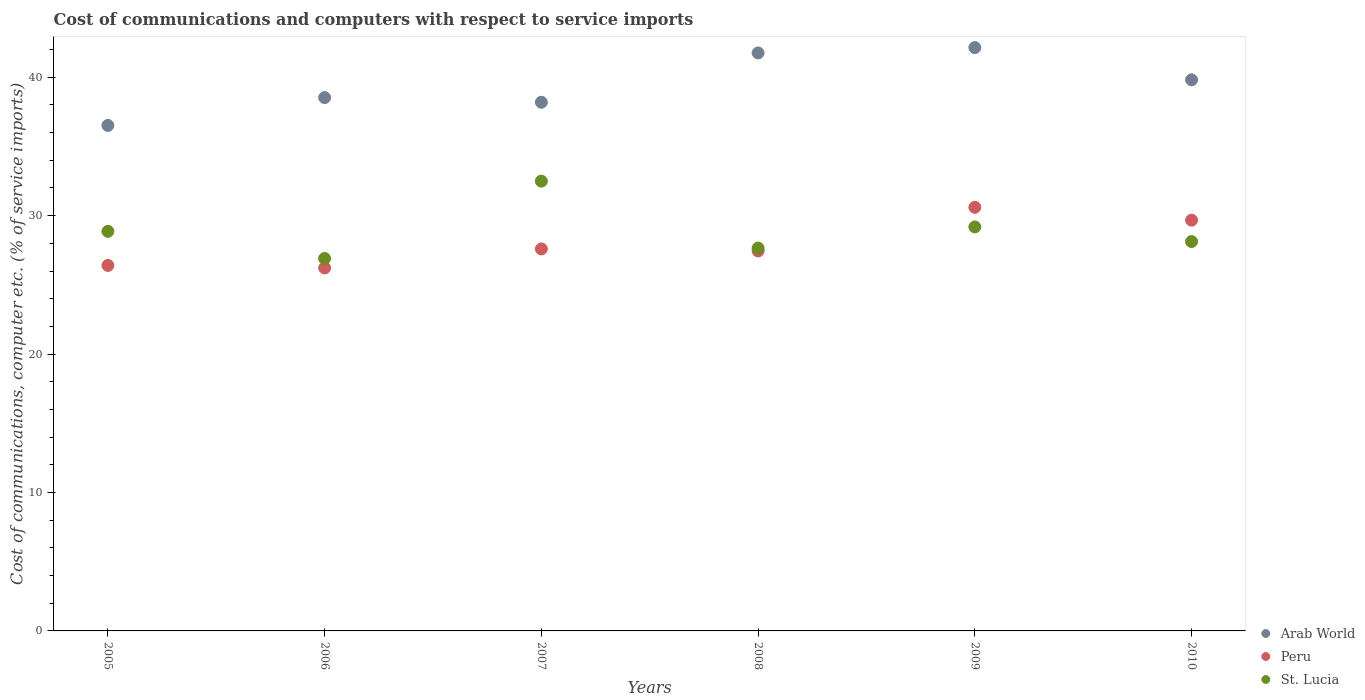How many different coloured dotlines are there?
Your answer should be very brief. 3. What is the cost of communications and computers in St. Lucia in 2005?
Your response must be concise. 28.86. Across all years, what is the maximum cost of communications and computers in Peru?
Give a very brief answer. 30.6. Across all years, what is the minimum cost of communications and computers in St. Lucia?
Offer a very short reply. 26.91. In which year was the cost of communications and computers in St. Lucia maximum?
Provide a succinct answer. 2007. What is the total cost of communications and computers in Peru in the graph?
Your response must be concise. 167.94. What is the difference between the cost of communications and computers in Arab World in 2007 and that in 2009?
Offer a very short reply. -3.95. What is the difference between the cost of communications and computers in St. Lucia in 2005 and the cost of communications and computers in Peru in 2007?
Your response must be concise. 1.27. What is the average cost of communications and computers in Peru per year?
Offer a very short reply. 27.99. In the year 2006, what is the difference between the cost of communications and computers in Peru and cost of communications and computers in Arab World?
Give a very brief answer. -12.3. In how many years, is the cost of communications and computers in Peru greater than 38 %?
Offer a very short reply. 0. What is the ratio of the cost of communications and computers in Peru in 2005 to that in 2009?
Give a very brief answer. 0.86. Is the cost of communications and computers in St. Lucia in 2008 less than that in 2009?
Offer a very short reply. Yes. Is the difference between the cost of communications and computers in Peru in 2008 and 2009 greater than the difference between the cost of communications and computers in Arab World in 2008 and 2009?
Your answer should be very brief. No. What is the difference between the highest and the second highest cost of communications and computers in Peru?
Offer a terse response. 0.93. What is the difference between the highest and the lowest cost of communications and computers in St. Lucia?
Ensure brevity in your answer.  5.59. Is the sum of the cost of communications and computers in Peru in 2009 and 2010 greater than the maximum cost of communications and computers in St. Lucia across all years?
Provide a short and direct response. Yes. Is it the case that in every year, the sum of the cost of communications and computers in Peru and cost of communications and computers in Arab World  is greater than the cost of communications and computers in St. Lucia?
Offer a very short reply. Yes. Is the cost of communications and computers in Peru strictly greater than the cost of communications and computers in St. Lucia over the years?
Give a very brief answer. No. Is the cost of communications and computers in St. Lucia strictly less than the cost of communications and computers in Peru over the years?
Make the answer very short. No. How many years are there in the graph?
Offer a terse response. 6. What is the difference between two consecutive major ticks on the Y-axis?
Make the answer very short. 10. Where does the legend appear in the graph?
Ensure brevity in your answer.  Bottom right. How are the legend labels stacked?
Give a very brief answer. Vertical. What is the title of the graph?
Keep it short and to the point. Cost of communications and computers with respect to service imports. Does "Suriname" appear as one of the legend labels in the graph?
Provide a short and direct response. No. What is the label or title of the X-axis?
Ensure brevity in your answer.  Years. What is the label or title of the Y-axis?
Your answer should be very brief. Cost of communications, computer etc. (% of service imports). What is the Cost of communications, computer etc. (% of service imports) of Arab World in 2005?
Your answer should be compact. 36.52. What is the Cost of communications, computer etc. (% of service imports) in Peru in 2005?
Your response must be concise. 26.4. What is the Cost of communications, computer etc. (% of service imports) of St. Lucia in 2005?
Your answer should be compact. 28.86. What is the Cost of communications, computer etc. (% of service imports) in Arab World in 2006?
Provide a short and direct response. 38.53. What is the Cost of communications, computer etc. (% of service imports) in Peru in 2006?
Your response must be concise. 26.22. What is the Cost of communications, computer etc. (% of service imports) of St. Lucia in 2006?
Your answer should be compact. 26.91. What is the Cost of communications, computer etc. (% of service imports) in Arab World in 2007?
Offer a very short reply. 38.19. What is the Cost of communications, computer etc. (% of service imports) of Peru in 2007?
Give a very brief answer. 27.59. What is the Cost of communications, computer etc. (% of service imports) in St. Lucia in 2007?
Make the answer very short. 32.49. What is the Cost of communications, computer etc. (% of service imports) of Arab World in 2008?
Provide a succinct answer. 41.75. What is the Cost of communications, computer etc. (% of service imports) of Peru in 2008?
Keep it short and to the point. 27.45. What is the Cost of communications, computer etc. (% of service imports) in St. Lucia in 2008?
Provide a short and direct response. 27.66. What is the Cost of communications, computer etc. (% of service imports) in Arab World in 2009?
Your response must be concise. 42.14. What is the Cost of communications, computer etc. (% of service imports) of Peru in 2009?
Your answer should be very brief. 30.6. What is the Cost of communications, computer etc. (% of service imports) of St. Lucia in 2009?
Your response must be concise. 29.18. What is the Cost of communications, computer etc. (% of service imports) of Arab World in 2010?
Your answer should be compact. 39.81. What is the Cost of communications, computer etc. (% of service imports) in Peru in 2010?
Keep it short and to the point. 29.67. What is the Cost of communications, computer etc. (% of service imports) in St. Lucia in 2010?
Your response must be concise. 28.13. Across all years, what is the maximum Cost of communications, computer etc. (% of service imports) in Arab World?
Ensure brevity in your answer.  42.14. Across all years, what is the maximum Cost of communications, computer etc. (% of service imports) in Peru?
Ensure brevity in your answer.  30.6. Across all years, what is the maximum Cost of communications, computer etc. (% of service imports) of St. Lucia?
Give a very brief answer. 32.49. Across all years, what is the minimum Cost of communications, computer etc. (% of service imports) in Arab World?
Offer a very short reply. 36.52. Across all years, what is the minimum Cost of communications, computer etc. (% of service imports) of Peru?
Give a very brief answer. 26.22. Across all years, what is the minimum Cost of communications, computer etc. (% of service imports) in St. Lucia?
Provide a short and direct response. 26.91. What is the total Cost of communications, computer etc. (% of service imports) of Arab World in the graph?
Ensure brevity in your answer.  236.93. What is the total Cost of communications, computer etc. (% of service imports) of Peru in the graph?
Your answer should be compact. 167.94. What is the total Cost of communications, computer etc. (% of service imports) in St. Lucia in the graph?
Offer a terse response. 173.23. What is the difference between the Cost of communications, computer etc. (% of service imports) in Arab World in 2005 and that in 2006?
Your response must be concise. -2.01. What is the difference between the Cost of communications, computer etc. (% of service imports) in Peru in 2005 and that in 2006?
Provide a short and direct response. 0.18. What is the difference between the Cost of communications, computer etc. (% of service imports) in St. Lucia in 2005 and that in 2006?
Offer a terse response. 1.96. What is the difference between the Cost of communications, computer etc. (% of service imports) in Arab World in 2005 and that in 2007?
Offer a very short reply. -1.67. What is the difference between the Cost of communications, computer etc. (% of service imports) in Peru in 2005 and that in 2007?
Make the answer very short. -1.19. What is the difference between the Cost of communications, computer etc. (% of service imports) in St. Lucia in 2005 and that in 2007?
Provide a succinct answer. -3.63. What is the difference between the Cost of communications, computer etc. (% of service imports) in Arab World in 2005 and that in 2008?
Make the answer very short. -5.24. What is the difference between the Cost of communications, computer etc. (% of service imports) in Peru in 2005 and that in 2008?
Make the answer very short. -1.04. What is the difference between the Cost of communications, computer etc. (% of service imports) in St. Lucia in 2005 and that in 2008?
Ensure brevity in your answer.  1.21. What is the difference between the Cost of communications, computer etc. (% of service imports) of Arab World in 2005 and that in 2009?
Give a very brief answer. -5.62. What is the difference between the Cost of communications, computer etc. (% of service imports) in Peru in 2005 and that in 2009?
Your answer should be very brief. -4.2. What is the difference between the Cost of communications, computer etc. (% of service imports) of St. Lucia in 2005 and that in 2009?
Provide a short and direct response. -0.32. What is the difference between the Cost of communications, computer etc. (% of service imports) of Arab World in 2005 and that in 2010?
Your answer should be compact. -3.29. What is the difference between the Cost of communications, computer etc. (% of service imports) in Peru in 2005 and that in 2010?
Your response must be concise. -3.27. What is the difference between the Cost of communications, computer etc. (% of service imports) of St. Lucia in 2005 and that in 2010?
Provide a succinct answer. 0.74. What is the difference between the Cost of communications, computer etc. (% of service imports) of Arab World in 2006 and that in 2007?
Ensure brevity in your answer.  0.34. What is the difference between the Cost of communications, computer etc. (% of service imports) of Peru in 2006 and that in 2007?
Provide a short and direct response. -1.37. What is the difference between the Cost of communications, computer etc. (% of service imports) in St. Lucia in 2006 and that in 2007?
Offer a terse response. -5.59. What is the difference between the Cost of communications, computer etc. (% of service imports) of Arab World in 2006 and that in 2008?
Give a very brief answer. -3.23. What is the difference between the Cost of communications, computer etc. (% of service imports) in Peru in 2006 and that in 2008?
Your response must be concise. -1.22. What is the difference between the Cost of communications, computer etc. (% of service imports) in St. Lucia in 2006 and that in 2008?
Make the answer very short. -0.75. What is the difference between the Cost of communications, computer etc. (% of service imports) of Arab World in 2006 and that in 2009?
Give a very brief answer. -3.61. What is the difference between the Cost of communications, computer etc. (% of service imports) of Peru in 2006 and that in 2009?
Provide a succinct answer. -4.38. What is the difference between the Cost of communications, computer etc. (% of service imports) of St. Lucia in 2006 and that in 2009?
Offer a terse response. -2.28. What is the difference between the Cost of communications, computer etc. (% of service imports) in Arab World in 2006 and that in 2010?
Your response must be concise. -1.28. What is the difference between the Cost of communications, computer etc. (% of service imports) of Peru in 2006 and that in 2010?
Give a very brief answer. -3.45. What is the difference between the Cost of communications, computer etc. (% of service imports) in St. Lucia in 2006 and that in 2010?
Ensure brevity in your answer.  -1.22. What is the difference between the Cost of communications, computer etc. (% of service imports) in Arab World in 2007 and that in 2008?
Your answer should be very brief. -3.56. What is the difference between the Cost of communications, computer etc. (% of service imports) of Peru in 2007 and that in 2008?
Your response must be concise. 0.15. What is the difference between the Cost of communications, computer etc. (% of service imports) of St. Lucia in 2007 and that in 2008?
Keep it short and to the point. 4.83. What is the difference between the Cost of communications, computer etc. (% of service imports) of Arab World in 2007 and that in 2009?
Your answer should be very brief. -3.95. What is the difference between the Cost of communications, computer etc. (% of service imports) in Peru in 2007 and that in 2009?
Provide a succinct answer. -3.01. What is the difference between the Cost of communications, computer etc. (% of service imports) in St. Lucia in 2007 and that in 2009?
Offer a very short reply. 3.31. What is the difference between the Cost of communications, computer etc. (% of service imports) in Arab World in 2007 and that in 2010?
Offer a terse response. -1.62. What is the difference between the Cost of communications, computer etc. (% of service imports) of Peru in 2007 and that in 2010?
Your response must be concise. -2.08. What is the difference between the Cost of communications, computer etc. (% of service imports) of St. Lucia in 2007 and that in 2010?
Your answer should be very brief. 4.36. What is the difference between the Cost of communications, computer etc. (% of service imports) in Arab World in 2008 and that in 2009?
Provide a short and direct response. -0.39. What is the difference between the Cost of communications, computer etc. (% of service imports) of Peru in 2008 and that in 2009?
Offer a very short reply. -3.16. What is the difference between the Cost of communications, computer etc. (% of service imports) in St. Lucia in 2008 and that in 2009?
Keep it short and to the point. -1.52. What is the difference between the Cost of communications, computer etc. (% of service imports) in Arab World in 2008 and that in 2010?
Offer a terse response. 1.94. What is the difference between the Cost of communications, computer etc. (% of service imports) in Peru in 2008 and that in 2010?
Your response must be concise. -2.23. What is the difference between the Cost of communications, computer etc. (% of service imports) of St. Lucia in 2008 and that in 2010?
Your answer should be compact. -0.47. What is the difference between the Cost of communications, computer etc. (% of service imports) of Arab World in 2009 and that in 2010?
Your answer should be compact. 2.33. What is the difference between the Cost of communications, computer etc. (% of service imports) in Peru in 2009 and that in 2010?
Give a very brief answer. 0.93. What is the difference between the Cost of communications, computer etc. (% of service imports) in St. Lucia in 2009 and that in 2010?
Offer a terse response. 1.06. What is the difference between the Cost of communications, computer etc. (% of service imports) in Arab World in 2005 and the Cost of communications, computer etc. (% of service imports) in Peru in 2006?
Your answer should be very brief. 10.29. What is the difference between the Cost of communications, computer etc. (% of service imports) of Arab World in 2005 and the Cost of communications, computer etc. (% of service imports) of St. Lucia in 2006?
Your response must be concise. 9.61. What is the difference between the Cost of communications, computer etc. (% of service imports) of Peru in 2005 and the Cost of communications, computer etc. (% of service imports) of St. Lucia in 2006?
Make the answer very short. -0.5. What is the difference between the Cost of communications, computer etc. (% of service imports) in Arab World in 2005 and the Cost of communications, computer etc. (% of service imports) in Peru in 2007?
Give a very brief answer. 8.92. What is the difference between the Cost of communications, computer etc. (% of service imports) in Arab World in 2005 and the Cost of communications, computer etc. (% of service imports) in St. Lucia in 2007?
Keep it short and to the point. 4.02. What is the difference between the Cost of communications, computer etc. (% of service imports) in Peru in 2005 and the Cost of communications, computer etc. (% of service imports) in St. Lucia in 2007?
Give a very brief answer. -6.09. What is the difference between the Cost of communications, computer etc. (% of service imports) in Arab World in 2005 and the Cost of communications, computer etc. (% of service imports) in Peru in 2008?
Your answer should be compact. 9.07. What is the difference between the Cost of communications, computer etc. (% of service imports) of Arab World in 2005 and the Cost of communications, computer etc. (% of service imports) of St. Lucia in 2008?
Your answer should be very brief. 8.86. What is the difference between the Cost of communications, computer etc. (% of service imports) in Peru in 2005 and the Cost of communications, computer etc. (% of service imports) in St. Lucia in 2008?
Give a very brief answer. -1.26. What is the difference between the Cost of communications, computer etc. (% of service imports) of Arab World in 2005 and the Cost of communications, computer etc. (% of service imports) of Peru in 2009?
Give a very brief answer. 5.92. What is the difference between the Cost of communications, computer etc. (% of service imports) in Arab World in 2005 and the Cost of communications, computer etc. (% of service imports) in St. Lucia in 2009?
Keep it short and to the point. 7.33. What is the difference between the Cost of communications, computer etc. (% of service imports) in Peru in 2005 and the Cost of communications, computer etc. (% of service imports) in St. Lucia in 2009?
Provide a succinct answer. -2.78. What is the difference between the Cost of communications, computer etc. (% of service imports) of Arab World in 2005 and the Cost of communications, computer etc. (% of service imports) of Peru in 2010?
Give a very brief answer. 6.84. What is the difference between the Cost of communications, computer etc. (% of service imports) of Arab World in 2005 and the Cost of communications, computer etc. (% of service imports) of St. Lucia in 2010?
Ensure brevity in your answer.  8.39. What is the difference between the Cost of communications, computer etc. (% of service imports) of Peru in 2005 and the Cost of communications, computer etc. (% of service imports) of St. Lucia in 2010?
Give a very brief answer. -1.73. What is the difference between the Cost of communications, computer etc. (% of service imports) of Arab World in 2006 and the Cost of communications, computer etc. (% of service imports) of Peru in 2007?
Keep it short and to the point. 10.93. What is the difference between the Cost of communications, computer etc. (% of service imports) in Arab World in 2006 and the Cost of communications, computer etc. (% of service imports) in St. Lucia in 2007?
Your response must be concise. 6.03. What is the difference between the Cost of communications, computer etc. (% of service imports) in Peru in 2006 and the Cost of communications, computer etc. (% of service imports) in St. Lucia in 2007?
Provide a short and direct response. -6.27. What is the difference between the Cost of communications, computer etc. (% of service imports) in Arab World in 2006 and the Cost of communications, computer etc. (% of service imports) in Peru in 2008?
Your answer should be compact. 11.08. What is the difference between the Cost of communications, computer etc. (% of service imports) in Arab World in 2006 and the Cost of communications, computer etc. (% of service imports) in St. Lucia in 2008?
Provide a succinct answer. 10.87. What is the difference between the Cost of communications, computer etc. (% of service imports) in Peru in 2006 and the Cost of communications, computer etc. (% of service imports) in St. Lucia in 2008?
Provide a short and direct response. -1.44. What is the difference between the Cost of communications, computer etc. (% of service imports) of Arab World in 2006 and the Cost of communications, computer etc. (% of service imports) of Peru in 2009?
Provide a short and direct response. 7.92. What is the difference between the Cost of communications, computer etc. (% of service imports) in Arab World in 2006 and the Cost of communications, computer etc. (% of service imports) in St. Lucia in 2009?
Ensure brevity in your answer.  9.34. What is the difference between the Cost of communications, computer etc. (% of service imports) in Peru in 2006 and the Cost of communications, computer etc. (% of service imports) in St. Lucia in 2009?
Provide a succinct answer. -2.96. What is the difference between the Cost of communications, computer etc. (% of service imports) in Arab World in 2006 and the Cost of communications, computer etc. (% of service imports) in Peru in 2010?
Provide a succinct answer. 8.85. What is the difference between the Cost of communications, computer etc. (% of service imports) of Arab World in 2006 and the Cost of communications, computer etc. (% of service imports) of St. Lucia in 2010?
Your response must be concise. 10.4. What is the difference between the Cost of communications, computer etc. (% of service imports) of Peru in 2006 and the Cost of communications, computer etc. (% of service imports) of St. Lucia in 2010?
Keep it short and to the point. -1.9. What is the difference between the Cost of communications, computer etc. (% of service imports) of Arab World in 2007 and the Cost of communications, computer etc. (% of service imports) of Peru in 2008?
Your response must be concise. 10.74. What is the difference between the Cost of communications, computer etc. (% of service imports) in Arab World in 2007 and the Cost of communications, computer etc. (% of service imports) in St. Lucia in 2008?
Your answer should be compact. 10.53. What is the difference between the Cost of communications, computer etc. (% of service imports) in Peru in 2007 and the Cost of communications, computer etc. (% of service imports) in St. Lucia in 2008?
Provide a short and direct response. -0.06. What is the difference between the Cost of communications, computer etc. (% of service imports) of Arab World in 2007 and the Cost of communications, computer etc. (% of service imports) of Peru in 2009?
Offer a terse response. 7.59. What is the difference between the Cost of communications, computer etc. (% of service imports) in Arab World in 2007 and the Cost of communications, computer etc. (% of service imports) in St. Lucia in 2009?
Your answer should be very brief. 9.01. What is the difference between the Cost of communications, computer etc. (% of service imports) in Peru in 2007 and the Cost of communications, computer etc. (% of service imports) in St. Lucia in 2009?
Your answer should be compact. -1.59. What is the difference between the Cost of communications, computer etc. (% of service imports) in Arab World in 2007 and the Cost of communications, computer etc. (% of service imports) in Peru in 2010?
Offer a terse response. 8.52. What is the difference between the Cost of communications, computer etc. (% of service imports) in Arab World in 2007 and the Cost of communications, computer etc. (% of service imports) in St. Lucia in 2010?
Your answer should be very brief. 10.06. What is the difference between the Cost of communications, computer etc. (% of service imports) of Peru in 2007 and the Cost of communications, computer etc. (% of service imports) of St. Lucia in 2010?
Ensure brevity in your answer.  -0.53. What is the difference between the Cost of communications, computer etc. (% of service imports) of Arab World in 2008 and the Cost of communications, computer etc. (% of service imports) of Peru in 2009?
Your answer should be very brief. 11.15. What is the difference between the Cost of communications, computer etc. (% of service imports) of Arab World in 2008 and the Cost of communications, computer etc. (% of service imports) of St. Lucia in 2009?
Give a very brief answer. 12.57. What is the difference between the Cost of communications, computer etc. (% of service imports) in Peru in 2008 and the Cost of communications, computer etc. (% of service imports) in St. Lucia in 2009?
Ensure brevity in your answer.  -1.74. What is the difference between the Cost of communications, computer etc. (% of service imports) of Arab World in 2008 and the Cost of communications, computer etc. (% of service imports) of Peru in 2010?
Your answer should be very brief. 12.08. What is the difference between the Cost of communications, computer etc. (% of service imports) of Arab World in 2008 and the Cost of communications, computer etc. (% of service imports) of St. Lucia in 2010?
Offer a very short reply. 13.63. What is the difference between the Cost of communications, computer etc. (% of service imports) of Peru in 2008 and the Cost of communications, computer etc. (% of service imports) of St. Lucia in 2010?
Make the answer very short. -0.68. What is the difference between the Cost of communications, computer etc. (% of service imports) of Arab World in 2009 and the Cost of communications, computer etc. (% of service imports) of Peru in 2010?
Keep it short and to the point. 12.47. What is the difference between the Cost of communications, computer etc. (% of service imports) of Arab World in 2009 and the Cost of communications, computer etc. (% of service imports) of St. Lucia in 2010?
Provide a short and direct response. 14.01. What is the difference between the Cost of communications, computer etc. (% of service imports) of Peru in 2009 and the Cost of communications, computer etc. (% of service imports) of St. Lucia in 2010?
Provide a short and direct response. 2.47. What is the average Cost of communications, computer etc. (% of service imports) of Arab World per year?
Provide a short and direct response. 39.49. What is the average Cost of communications, computer etc. (% of service imports) in Peru per year?
Keep it short and to the point. 27.99. What is the average Cost of communications, computer etc. (% of service imports) of St. Lucia per year?
Your answer should be very brief. 28.87. In the year 2005, what is the difference between the Cost of communications, computer etc. (% of service imports) of Arab World and Cost of communications, computer etc. (% of service imports) of Peru?
Provide a short and direct response. 10.11. In the year 2005, what is the difference between the Cost of communications, computer etc. (% of service imports) in Arab World and Cost of communications, computer etc. (% of service imports) in St. Lucia?
Keep it short and to the point. 7.65. In the year 2005, what is the difference between the Cost of communications, computer etc. (% of service imports) in Peru and Cost of communications, computer etc. (% of service imports) in St. Lucia?
Your answer should be compact. -2.46. In the year 2006, what is the difference between the Cost of communications, computer etc. (% of service imports) of Arab World and Cost of communications, computer etc. (% of service imports) of Peru?
Your answer should be compact. 12.3. In the year 2006, what is the difference between the Cost of communications, computer etc. (% of service imports) in Arab World and Cost of communications, computer etc. (% of service imports) in St. Lucia?
Give a very brief answer. 11.62. In the year 2006, what is the difference between the Cost of communications, computer etc. (% of service imports) of Peru and Cost of communications, computer etc. (% of service imports) of St. Lucia?
Provide a succinct answer. -0.68. In the year 2007, what is the difference between the Cost of communications, computer etc. (% of service imports) of Arab World and Cost of communications, computer etc. (% of service imports) of Peru?
Your answer should be very brief. 10.6. In the year 2007, what is the difference between the Cost of communications, computer etc. (% of service imports) of Arab World and Cost of communications, computer etc. (% of service imports) of St. Lucia?
Offer a terse response. 5.7. In the year 2007, what is the difference between the Cost of communications, computer etc. (% of service imports) in Peru and Cost of communications, computer etc. (% of service imports) in St. Lucia?
Your answer should be compact. -4.9. In the year 2008, what is the difference between the Cost of communications, computer etc. (% of service imports) in Arab World and Cost of communications, computer etc. (% of service imports) in Peru?
Keep it short and to the point. 14.31. In the year 2008, what is the difference between the Cost of communications, computer etc. (% of service imports) of Arab World and Cost of communications, computer etc. (% of service imports) of St. Lucia?
Your answer should be very brief. 14.09. In the year 2008, what is the difference between the Cost of communications, computer etc. (% of service imports) of Peru and Cost of communications, computer etc. (% of service imports) of St. Lucia?
Offer a terse response. -0.21. In the year 2009, what is the difference between the Cost of communications, computer etc. (% of service imports) in Arab World and Cost of communications, computer etc. (% of service imports) in Peru?
Give a very brief answer. 11.54. In the year 2009, what is the difference between the Cost of communications, computer etc. (% of service imports) in Arab World and Cost of communications, computer etc. (% of service imports) in St. Lucia?
Ensure brevity in your answer.  12.96. In the year 2009, what is the difference between the Cost of communications, computer etc. (% of service imports) in Peru and Cost of communications, computer etc. (% of service imports) in St. Lucia?
Offer a terse response. 1.42. In the year 2010, what is the difference between the Cost of communications, computer etc. (% of service imports) of Arab World and Cost of communications, computer etc. (% of service imports) of Peru?
Keep it short and to the point. 10.14. In the year 2010, what is the difference between the Cost of communications, computer etc. (% of service imports) in Arab World and Cost of communications, computer etc. (% of service imports) in St. Lucia?
Ensure brevity in your answer.  11.68. In the year 2010, what is the difference between the Cost of communications, computer etc. (% of service imports) in Peru and Cost of communications, computer etc. (% of service imports) in St. Lucia?
Your response must be concise. 1.54. What is the ratio of the Cost of communications, computer etc. (% of service imports) of Arab World in 2005 to that in 2006?
Offer a very short reply. 0.95. What is the ratio of the Cost of communications, computer etc. (% of service imports) in Peru in 2005 to that in 2006?
Ensure brevity in your answer.  1.01. What is the ratio of the Cost of communications, computer etc. (% of service imports) of St. Lucia in 2005 to that in 2006?
Give a very brief answer. 1.07. What is the ratio of the Cost of communications, computer etc. (% of service imports) of Arab World in 2005 to that in 2007?
Offer a very short reply. 0.96. What is the ratio of the Cost of communications, computer etc. (% of service imports) in Peru in 2005 to that in 2007?
Make the answer very short. 0.96. What is the ratio of the Cost of communications, computer etc. (% of service imports) in St. Lucia in 2005 to that in 2007?
Make the answer very short. 0.89. What is the ratio of the Cost of communications, computer etc. (% of service imports) in Arab World in 2005 to that in 2008?
Your response must be concise. 0.87. What is the ratio of the Cost of communications, computer etc. (% of service imports) in St. Lucia in 2005 to that in 2008?
Your answer should be compact. 1.04. What is the ratio of the Cost of communications, computer etc. (% of service imports) of Arab World in 2005 to that in 2009?
Your response must be concise. 0.87. What is the ratio of the Cost of communications, computer etc. (% of service imports) in Peru in 2005 to that in 2009?
Make the answer very short. 0.86. What is the ratio of the Cost of communications, computer etc. (% of service imports) of St. Lucia in 2005 to that in 2009?
Provide a short and direct response. 0.99. What is the ratio of the Cost of communications, computer etc. (% of service imports) in Arab World in 2005 to that in 2010?
Offer a very short reply. 0.92. What is the ratio of the Cost of communications, computer etc. (% of service imports) in Peru in 2005 to that in 2010?
Your answer should be compact. 0.89. What is the ratio of the Cost of communications, computer etc. (% of service imports) in St. Lucia in 2005 to that in 2010?
Your answer should be compact. 1.03. What is the ratio of the Cost of communications, computer etc. (% of service imports) in Arab World in 2006 to that in 2007?
Your answer should be very brief. 1.01. What is the ratio of the Cost of communications, computer etc. (% of service imports) of Peru in 2006 to that in 2007?
Offer a very short reply. 0.95. What is the ratio of the Cost of communications, computer etc. (% of service imports) in St. Lucia in 2006 to that in 2007?
Keep it short and to the point. 0.83. What is the ratio of the Cost of communications, computer etc. (% of service imports) in Arab World in 2006 to that in 2008?
Offer a terse response. 0.92. What is the ratio of the Cost of communications, computer etc. (% of service imports) in Peru in 2006 to that in 2008?
Ensure brevity in your answer.  0.96. What is the ratio of the Cost of communications, computer etc. (% of service imports) in St. Lucia in 2006 to that in 2008?
Your answer should be very brief. 0.97. What is the ratio of the Cost of communications, computer etc. (% of service imports) of Arab World in 2006 to that in 2009?
Offer a very short reply. 0.91. What is the ratio of the Cost of communications, computer etc. (% of service imports) in Peru in 2006 to that in 2009?
Provide a succinct answer. 0.86. What is the ratio of the Cost of communications, computer etc. (% of service imports) of St. Lucia in 2006 to that in 2009?
Provide a succinct answer. 0.92. What is the ratio of the Cost of communications, computer etc. (% of service imports) in Peru in 2006 to that in 2010?
Ensure brevity in your answer.  0.88. What is the ratio of the Cost of communications, computer etc. (% of service imports) in St. Lucia in 2006 to that in 2010?
Give a very brief answer. 0.96. What is the ratio of the Cost of communications, computer etc. (% of service imports) of Arab World in 2007 to that in 2008?
Your answer should be very brief. 0.91. What is the ratio of the Cost of communications, computer etc. (% of service imports) in Peru in 2007 to that in 2008?
Your response must be concise. 1.01. What is the ratio of the Cost of communications, computer etc. (% of service imports) in St. Lucia in 2007 to that in 2008?
Ensure brevity in your answer.  1.17. What is the ratio of the Cost of communications, computer etc. (% of service imports) in Arab World in 2007 to that in 2009?
Keep it short and to the point. 0.91. What is the ratio of the Cost of communications, computer etc. (% of service imports) of Peru in 2007 to that in 2009?
Your answer should be compact. 0.9. What is the ratio of the Cost of communications, computer etc. (% of service imports) in St. Lucia in 2007 to that in 2009?
Offer a very short reply. 1.11. What is the ratio of the Cost of communications, computer etc. (% of service imports) in Arab World in 2007 to that in 2010?
Ensure brevity in your answer.  0.96. What is the ratio of the Cost of communications, computer etc. (% of service imports) of St. Lucia in 2007 to that in 2010?
Ensure brevity in your answer.  1.16. What is the ratio of the Cost of communications, computer etc. (% of service imports) of Arab World in 2008 to that in 2009?
Keep it short and to the point. 0.99. What is the ratio of the Cost of communications, computer etc. (% of service imports) of Peru in 2008 to that in 2009?
Ensure brevity in your answer.  0.9. What is the ratio of the Cost of communications, computer etc. (% of service imports) in St. Lucia in 2008 to that in 2009?
Offer a very short reply. 0.95. What is the ratio of the Cost of communications, computer etc. (% of service imports) in Arab World in 2008 to that in 2010?
Give a very brief answer. 1.05. What is the ratio of the Cost of communications, computer etc. (% of service imports) of Peru in 2008 to that in 2010?
Make the answer very short. 0.93. What is the ratio of the Cost of communications, computer etc. (% of service imports) of St. Lucia in 2008 to that in 2010?
Your response must be concise. 0.98. What is the ratio of the Cost of communications, computer etc. (% of service imports) in Arab World in 2009 to that in 2010?
Your response must be concise. 1.06. What is the ratio of the Cost of communications, computer etc. (% of service imports) of Peru in 2009 to that in 2010?
Your response must be concise. 1.03. What is the ratio of the Cost of communications, computer etc. (% of service imports) in St. Lucia in 2009 to that in 2010?
Provide a short and direct response. 1.04. What is the difference between the highest and the second highest Cost of communications, computer etc. (% of service imports) in Arab World?
Provide a short and direct response. 0.39. What is the difference between the highest and the second highest Cost of communications, computer etc. (% of service imports) in Peru?
Make the answer very short. 0.93. What is the difference between the highest and the second highest Cost of communications, computer etc. (% of service imports) in St. Lucia?
Keep it short and to the point. 3.31. What is the difference between the highest and the lowest Cost of communications, computer etc. (% of service imports) of Arab World?
Ensure brevity in your answer.  5.62. What is the difference between the highest and the lowest Cost of communications, computer etc. (% of service imports) in Peru?
Offer a terse response. 4.38. What is the difference between the highest and the lowest Cost of communications, computer etc. (% of service imports) in St. Lucia?
Ensure brevity in your answer.  5.59. 